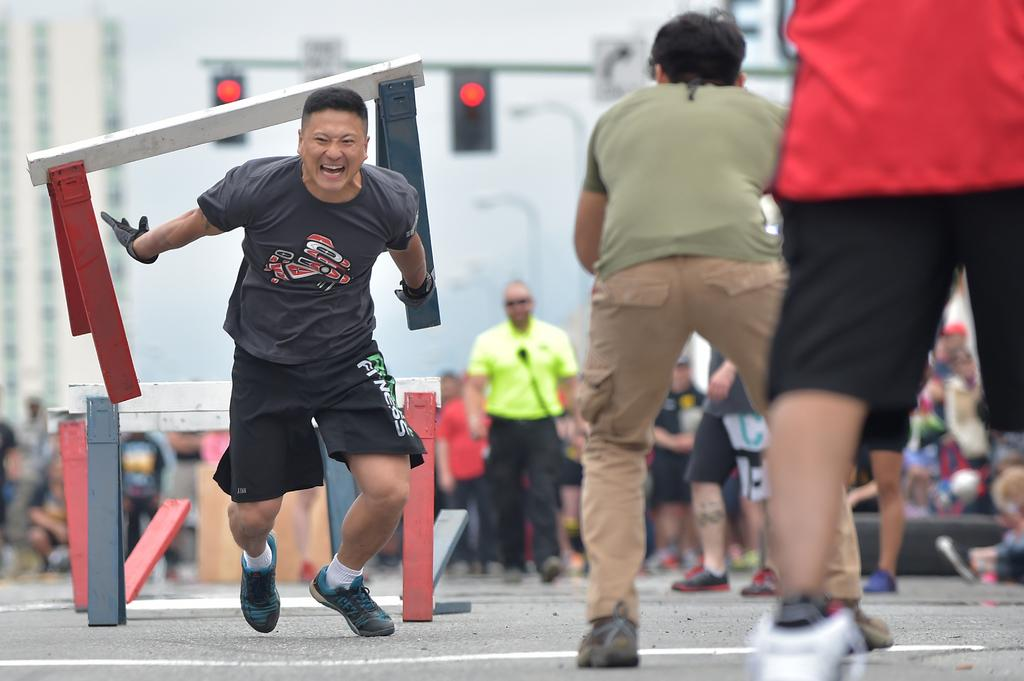What is the man in the image doing? The man is running in the image. What obstacles are present in the image? There are hurdles in the image. What can be seen on a pole in the image? There are signal lights on a pole in the image. Can you describe the people in the image? There is a group of people in the image. How is the background of the image depicted? The background of the image is blurred. What type of alley can be seen in the background of the image? There is no alley present in the image; the background is blurred and does not show any specific location or setting. 